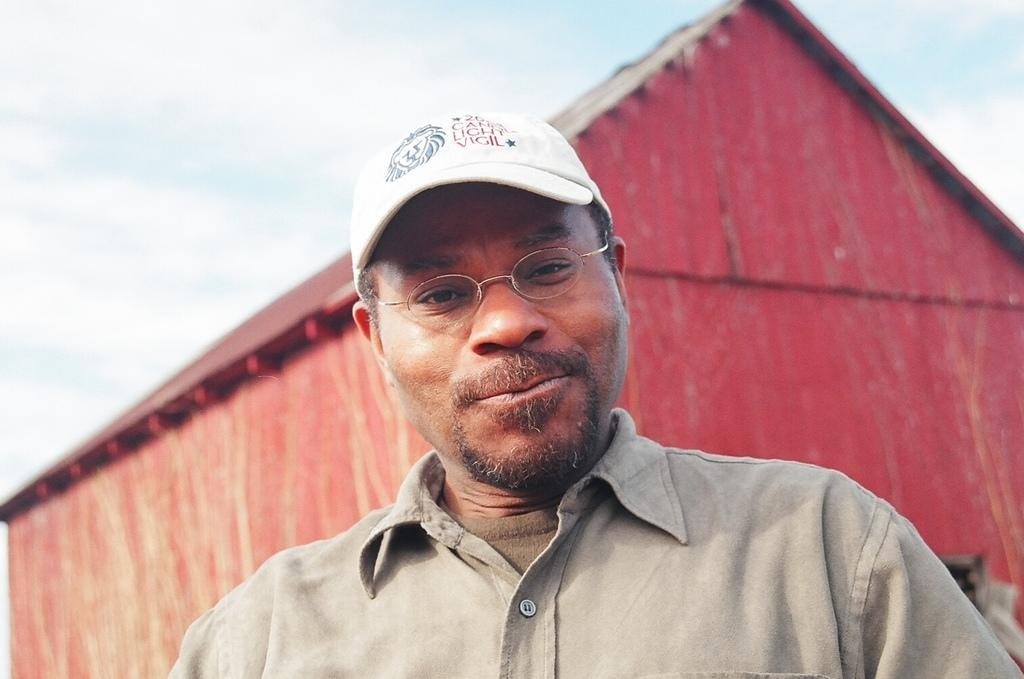How would you summarize this image in a sentence or two? In the middle of the image I can see a person standing wearing the cap. In the background, I can see the house. 